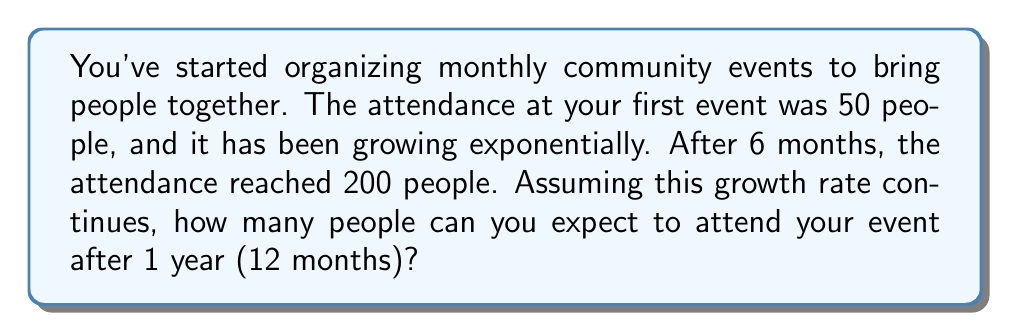Can you solve this math problem? Let's approach this step-by-step using an exponential growth model:

1) The general form of exponential growth is:
   $$A(t) = A_0 \cdot e^{rt}$$
   Where $A(t)$ is the attendance at time $t$, $A_0$ is the initial attendance, $r$ is the growth rate, and $t$ is the time.

2) We know:
   - Initial attendance $A_0 = 50$
   - After 6 months, $A(6) = 200$
   - We need to find $A(12)$

3) Let's find the growth rate $r$ using the 6-month data:
   $$200 = 50 \cdot e^{6r}$$

4) Divide both sides by 50:
   $$4 = e^{6r}$$

5) Take the natural log of both sides:
   $$\ln(4) = 6r$$

6) Solve for $r$:
   $$r = \frac{\ln(4)}{6} \approx 0.231$$

7) Now that we have $r$, we can predict the attendance after 12 months:
   $$A(12) = 50 \cdot e^{0.231 \cdot 12}$$

8) Calculate:
   $$A(12) = 50 \cdot e^{2.772} \approx 800.33$$

Therefore, you can expect approximately 800 people to attend your event after 1 year.
Answer: 800 people 